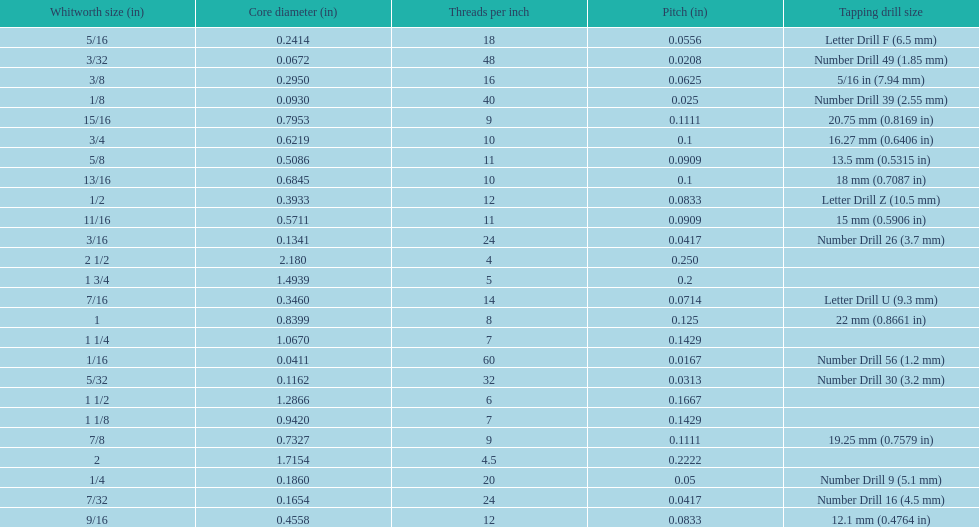What core diameter (in) comes after 0.0930? 0.1162. 